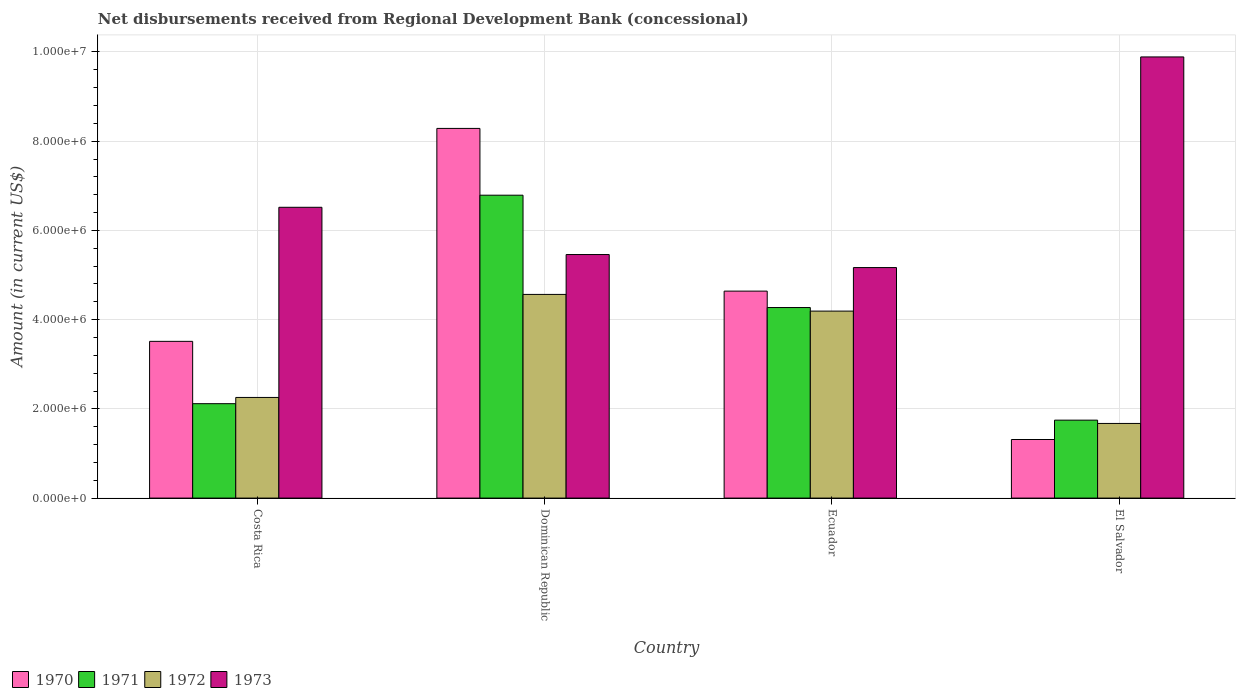How many different coloured bars are there?
Give a very brief answer. 4. How many bars are there on the 1st tick from the left?
Your answer should be compact. 4. How many bars are there on the 3rd tick from the right?
Your answer should be compact. 4. What is the label of the 4th group of bars from the left?
Give a very brief answer. El Salvador. In how many cases, is the number of bars for a given country not equal to the number of legend labels?
Give a very brief answer. 0. What is the amount of disbursements received from Regional Development Bank in 1972 in Costa Rica?
Your response must be concise. 2.26e+06. Across all countries, what is the maximum amount of disbursements received from Regional Development Bank in 1971?
Your response must be concise. 6.79e+06. Across all countries, what is the minimum amount of disbursements received from Regional Development Bank in 1971?
Your answer should be compact. 1.75e+06. In which country was the amount of disbursements received from Regional Development Bank in 1970 maximum?
Ensure brevity in your answer.  Dominican Republic. In which country was the amount of disbursements received from Regional Development Bank in 1972 minimum?
Offer a very short reply. El Salvador. What is the total amount of disbursements received from Regional Development Bank in 1971 in the graph?
Offer a terse response. 1.49e+07. What is the difference between the amount of disbursements received from Regional Development Bank in 1971 in Costa Rica and that in El Salvador?
Make the answer very short. 3.69e+05. What is the difference between the amount of disbursements received from Regional Development Bank in 1972 in Costa Rica and the amount of disbursements received from Regional Development Bank in 1973 in Dominican Republic?
Keep it short and to the point. -3.20e+06. What is the average amount of disbursements received from Regional Development Bank in 1971 per country?
Keep it short and to the point. 3.73e+06. What is the difference between the amount of disbursements received from Regional Development Bank of/in 1972 and amount of disbursements received from Regional Development Bank of/in 1973 in Costa Rica?
Give a very brief answer. -4.26e+06. In how many countries, is the amount of disbursements received from Regional Development Bank in 1972 greater than 2400000 US$?
Ensure brevity in your answer.  2. What is the ratio of the amount of disbursements received from Regional Development Bank in 1972 in Costa Rica to that in Ecuador?
Give a very brief answer. 0.54. Is the difference between the amount of disbursements received from Regional Development Bank in 1972 in Costa Rica and Ecuador greater than the difference between the amount of disbursements received from Regional Development Bank in 1973 in Costa Rica and Ecuador?
Provide a succinct answer. No. What is the difference between the highest and the second highest amount of disbursements received from Regional Development Bank in 1970?
Make the answer very short. 3.65e+06. What is the difference between the highest and the lowest amount of disbursements received from Regional Development Bank in 1973?
Your response must be concise. 4.72e+06. In how many countries, is the amount of disbursements received from Regional Development Bank in 1970 greater than the average amount of disbursements received from Regional Development Bank in 1970 taken over all countries?
Your answer should be very brief. 2. Is the sum of the amount of disbursements received from Regional Development Bank in 1971 in Costa Rica and Dominican Republic greater than the maximum amount of disbursements received from Regional Development Bank in 1970 across all countries?
Keep it short and to the point. Yes. Is it the case that in every country, the sum of the amount of disbursements received from Regional Development Bank in 1970 and amount of disbursements received from Regional Development Bank in 1971 is greater than the amount of disbursements received from Regional Development Bank in 1972?
Offer a very short reply. Yes. How many countries are there in the graph?
Make the answer very short. 4. Are the values on the major ticks of Y-axis written in scientific E-notation?
Give a very brief answer. Yes. Does the graph contain any zero values?
Offer a terse response. No. Does the graph contain grids?
Keep it short and to the point. Yes. Where does the legend appear in the graph?
Ensure brevity in your answer.  Bottom left. How many legend labels are there?
Your answer should be very brief. 4. How are the legend labels stacked?
Provide a short and direct response. Horizontal. What is the title of the graph?
Give a very brief answer. Net disbursements received from Regional Development Bank (concessional). Does "2014" appear as one of the legend labels in the graph?
Ensure brevity in your answer.  No. What is the Amount (in current US$) of 1970 in Costa Rica?
Offer a very short reply. 3.51e+06. What is the Amount (in current US$) in 1971 in Costa Rica?
Ensure brevity in your answer.  2.12e+06. What is the Amount (in current US$) of 1972 in Costa Rica?
Provide a succinct answer. 2.26e+06. What is the Amount (in current US$) in 1973 in Costa Rica?
Offer a very short reply. 6.52e+06. What is the Amount (in current US$) in 1970 in Dominican Republic?
Offer a very short reply. 8.29e+06. What is the Amount (in current US$) of 1971 in Dominican Republic?
Ensure brevity in your answer.  6.79e+06. What is the Amount (in current US$) in 1972 in Dominican Republic?
Make the answer very short. 4.56e+06. What is the Amount (in current US$) of 1973 in Dominican Republic?
Make the answer very short. 5.46e+06. What is the Amount (in current US$) in 1970 in Ecuador?
Ensure brevity in your answer.  4.64e+06. What is the Amount (in current US$) of 1971 in Ecuador?
Make the answer very short. 4.27e+06. What is the Amount (in current US$) in 1972 in Ecuador?
Give a very brief answer. 4.19e+06. What is the Amount (in current US$) in 1973 in Ecuador?
Give a very brief answer. 5.17e+06. What is the Amount (in current US$) of 1970 in El Salvador?
Your answer should be compact. 1.31e+06. What is the Amount (in current US$) of 1971 in El Salvador?
Your answer should be compact. 1.75e+06. What is the Amount (in current US$) of 1972 in El Salvador?
Your response must be concise. 1.67e+06. What is the Amount (in current US$) in 1973 in El Salvador?
Offer a terse response. 9.89e+06. Across all countries, what is the maximum Amount (in current US$) of 1970?
Ensure brevity in your answer.  8.29e+06. Across all countries, what is the maximum Amount (in current US$) of 1971?
Make the answer very short. 6.79e+06. Across all countries, what is the maximum Amount (in current US$) in 1972?
Keep it short and to the point. 4.56e+06. Across all countries, what is the maximum Amount (in current US$) in 1973?
Your answer should be very brief. 9.89e+06. Across all countries, what is the minimum Amount (in current US$) in 1970?
Make the answer very short. 1.31e+06. Across all countries, what is the minimum Amount (in current US$) of 1971?
Offer a very short reply. 1.75e+06. Across all countries, what is the minimum Amount (in current US$) of 1972?
Provide a short and direct response. 1.67e+06. Across all countries, what is the minimum Amount (in current US$) of 1973?
Offer a very short reply. 5.17e+06. What is the total Amount (in current US$) of 1970 in the graph?
Provide a short and direct response. 1.78e+07. What is the total Amount (in current US$) in 1971 in the graph?
Make the answer very short. 1.49e+07. What is the total Amount (in current US$) of 1972 in the graph?
Provide a succinct answer. 1.27e+07. What is the total Amount (in current US$) of 1973 in the graph?
Make the answer very short. 2.70e+07. What is the difference between the Amount (in current US$) in 1970 in Costa Rica and that in Dominican Republic?
Offer a terse response. -4.77e+06. What is the difference between the Amount (in current US$) in 1971 in Costa Rica and that in Dominican Republic?
Make the answer very short. -4.67e+06. What is the difference between the Amount (in current US$) of 1972 in Costa Rica and that in Dominican Republic?
Your answer should be compact. -2.31e+06. What is the difference between the Amount (in current US$) of 1973 in Costa Rica and that in Dominican Republic?
Your answer should be very brief. 1.06e+06. What is the difference between the Amount (in current US$) in 1970 in Costa Rica and that in Ecuador?
Ensure brevity in your answer.  -1.13e+06. What is the difference between the Amount (in current US$) in 1971 in Costa Rica and that in Ecuador?
Your response must be concise. -2.16e+06. What is the difference between the Amount (in current US$) of 1972 in Costa Rica and that in Ecuador?
Your response must be concise. -1.94e+06. What is the difference between the Amount (in current US$) in 1973 in Costa Rica and that in Ecuador?
Provide a short and direct response. 1.35e+06. What is the difference between the Amount (in current US$) of 1970 in Costa Rica and that in El Salvador?
Offer a very short reply. 2.20e+06. What is the difference between the Amount (in current US$) in 1971 in Costa Rica and that in El Salvador?
Offer a terse response. 3.69e+05. What is the difference between the Amount (in current US$) of 1972 in Costa Rica and that in El Salvador?
Offer a terse response. 5.83e+05. What is the difference between the Amount (in current US$) in 1973 in Costa Rica and that in El Salvador?
Ensure brevity in your answer.  -3.37e+06. What is the difference between the Amount (in current US$) of 1970 in Dominican Republic and that in Ecuador?
Ensure brevity in your answer.  3.65e+06. What is the difference between the Amount (in current US$) of 1971 in Dominican Republic and that in Ecuador?
Offer a very short reply. 2.52e+06. What is the difference between the Amount (in current US$) of 1972 in Dominican Republic and that in Ecuador?
Your response must be concise. 3.74e+05. What is the difference between the Amount (in current US$) in 1973 in Dominican Republic and that in Ecuador?
Your answer should be very brief. 2.92e+05. What is the difference between the Amount (in current US$) of 1970 in Dominican Republic and that in El Salvador?
Keep it short and to the point. 6.97e+06. What is the difference between the Amount (in current US$) in 1971 in Dominican Republic and that in El Salvador?
Provide a succinct answer. 5.04e+06. What is the difference between the Amount (in current US$) in 1972 in Dominican Republic and that in El Salvador?
Provide a short and direct response. 2.89e+06. What is the difference between the Amount (in current US$) of 1973 in Dominican Republic and that in El Salvador?
Your response must be concise. -4.43e+06. What is the difference between the Amount (in current US$) of 1970 in Ecuador and that in El Salvador?
Your answer should be very brief. 3.33e+06. What is the difference between the Amount (in current US$) of 1971 in Ecuador and that in El Salvador?
Make the answer very short. 2.52e+06. What is the difference between the Amount (in current US$) in 1972 in Ecuador and that in El Salvador?
Offer a very short reply. 2.52e+06. What is the difference between the Amount (in current US$) of 1973 in Ecuador and that in El Salvador?
Your answer should be very brief. -4.72e+06. What is the difference between the Amount (in current US$) in 1970 in Costa Rica and the Amount (in current US$) in 1971 in Dominican Republic?
Your answer should be compact. -3.28e+06. What is the difference between the Amount (in current US$) of 1970 in Costa Rica and the Amount (in current US$) of 1972 in Dominican Republic?
Provide a succinct answer. -1.05e+06. What is the difference between the Amount (in current US$) of 1970 in Costa Rica and the Amount (in current US$) of 1973 in Dominican Republic?
Provide a succinct answer. -1.95e+06. What is the difference between the Amount (in current US$) in 1971 in Costa Rica and the Amount (in current US$) in 1972 in Dominican Republic?
Ensure brevity in your answer.  -2.45e+06. What is the difference between the Amount (in current US$) of 1971 in Costa Rica and the Amount (in current US$) of 1973 in Dominican Republic?
Your answer should be very brief. -3.34e+06. What is the difference between the Amount (in current US$) in 1972 in Costa Rica and the Amount (in current US$) in 1973 in Dominican Republic?
Ensure brevity in your answer.  -3.20e+06. What is the difference between the Amount (in current US$) of 1970 in Costa Rica and the Amount (in current US$) of 1971 in Ecuador?
Your response must be concise. -7.58e+05. What is the difference between the Amount (in current US$) of 1970 in Costa Rica and the Amount (in current US$) of 1972 in Ecuador?
Your answer should be very brief. -6.78e+05. What is the difference between the Amount (in current US$) of 1970 in Costa Rica and the Amount (in current US$) of 1973 in Ecuador?
Offer a terse response. -1.65e+06. What is the difference between the Amount (in current US$) in 1971 in Costa Rica and the Amount (in current US$) in 1972 in Ecuador?
Provide a short and direct response. -2.08e+06. What is the difference between the Amount (in current US$) of 1971 in Costa Rica and the Amount (in current US$) of 1973 in Ecuador?
Ensure brevity in your answer.  -3.05e+06. What is the difference between the Amount (in current US$) in 1972 in Costa Rica and the Amount (in current US$) in 1973 in Ecuador?
Your response must be concise. -2.91e+06. What is the difference between the Amount (in current US$) in 1970 in Costa Rica and the Amount (in current US$) in 1971 in El Salvador?
Your answer should be compact. 1.77e+06. What is the difference between the Amount (in current US$) of 1970 in Costa Rica and the Amount (in current US$) of 1972 in El Salvador?
Give a very brief answer. 1.84e+06. What is the difference between the Amount (in current US$) in 1970 in Costa Rica and the Amount (in current US$) in 1973 in El Salvador?
Your answer should be very brief. -6.38e+06. What is the difference between the Amount (in current US$) in 1971 in Costa Rica and the Amount (in current US$) in 1972 in El Salvador?
Your answer should be very brief. 4.43e+05. What is the difference between the Amount (in current US$) in 1971 in Costa Rica and the Amount (in current US$) in 1973 in El Salvador?
Your response must be concise. -7.77e+06. What is the difference between the Amount (in current US$) of 1972 in Costa Rica and the Amount (in current US$) of 1973 in El Salvador?
Make the answer very short. -7.63e+06. What is the difference between the Amount (in current US$) of 1970 in Dominican Republic and the Amount (in current US$) of 1971 in Ecuador?
Make the answer very short. 4.02e+06. What is the difference between the Amount (in current US$) of 1970 in Dominican Republic and the Amount (in current US$) of 1972 in Ecuador?
Ensure brevity in your answer.  4.10e+06. What is the difference between the Amount (in current US$) of 1970 in Dominican Republic and the Amount (in current US$) of 1973 in Ecuador?
Make the answer very short. 3.12e+06. What is the difference between the Amount (in current US$) of 1971 in Dominican Republic and the Amount (in current US$) of 1972 in Ecuador?
Offer a very short reply. 2.60e+06. What is the difference between the Amount (in current US$) in 1971 in Dominican Republic and the Amount (in current US$) in 1973 in Ecuador?
Your response must be concise. 1.62e+06. What is the difference between the Amount (in current US$) in 1972 in Dominican Republic and the Amount (in current US$) in 1973 in Ecuador?
Offer a terse response. -6.02e+05. What is the difference between the Amount (in current US$) of 1970 in Dominican Republic and the Amount (in current US$) of 1971 in El Salvador?
Make the answer very short. 6.54e+06. What is the difference between the Amount (in current US$) of 1970 in Dominican Republic and the Amount (in current US$) of 1972 in El Salvador?
Provide a short and direct response. 6.61e+06. What is the difference between the Amount (in current US$) of 1970 in Dominican Republic and the Amount (in current US$) of 1973 in El Salvador?
Ensure brevity in your answer.  -1.60e+06. What is the difference between the Amount (in current US$) of 1971 in Dominican Republic and the Amount (in current US$) of 1972 in El Salvador?
Provide a succinct answer. 5.12e+06. What is the difference between the Amount (in current US$) of 1971 in Dominican Republic and the Amount (in current US$) of 1973 in El Salvador?
Your response must be concise. -3.10e+06. What is the difference between the Amount (in current US$) in 1972 in Dominican Republic and the Amount (in current US$) in 1973 in El Salvador?
Give a very brief answer. -5.32e+06. What is the difference between the Amount (in current US$) of 1970 in Ecuador and the Amount (in current US$) of 1971 in El Salvador?
Give a very brief answer. 2.89e+06. What is the difference between the Amount (in current US$) of 1970 in Ecuador and the Amount (in current US$) of 1972 in El Salvador?
Give a very brief answer. 2.97e+06. What is the difference between the Amount (in current US$) in 1970 in Ecuador and the Amount (in current US$) in 1973 in El Salvador?
Provide a succinct answer. -5.25e+06. What is the difference between the Amount (in current US$) of 1971 in Ecuador and the Amount (in current US$) of 1972 in El Salvador?
Give a very brief answer. 2.60e+06. What is the difference between the Amount (in current US$) in 1971 in Ecuador and the Amount (in current US$) in 1973 in El Salvador?
Give a very brief answer. -5.62e+06. What is the difference between the Amount (in current US$) in 1972 in Ecuador and the Amount (in current US$) in 1973 in El Salvador?
Offer a terse response. -5.70e+06. What is the average Amount (in current US$) of 1970 per country?
Your answer should be compact. 4.44e+06. What is the average Amount (in current US$) in 1971 per country?
Ensure brevity in your answer.  3.73e+06. What is the average Amount (in current US$) in 1972 per country?
Provide a short and direct response. 3.17e+06. What is the average Amount (in current US$) in 1973 per country?
Keep it short and to the point. 6.76e+06. What is the difference between the Amount (in current US$) of 1970 and Amount (in current US$) of 1971 in Costa Rica?
Your answer should be compact. 1.40e+06. What is the difference between the Amount (in current US$) in 1970 and Amount (in current US$) in 1972 in Costa Rica?
Provide a succinct answer. 1.26e+06. What is the difference between the Amount (in current US$) in 1970 and Amount (in current US$) in 1973 in Costa Rica?
Keep it short and to the point. -3.00e+06. What is the difference between the Amount (in current US$) of 1971 and Amount (in current US$) of 1973 in Costa Rica?
Make the answer very short. -4.40e+06. What is the difference between the Amount (in current US$) of 1972 and Amount (in current US$) of 1973 in Costa Rica?
Give a very brief answer. -4.26e+06. What is the difference between the Amount (in current US$) in 1970 and Amount (in current US$) in 1971 in Dominican Republic?
Ensure brevity in your answer.  1.50e+06. What is the difference between the Amount (in current US$) of 1970 and Amount (in current US$) of 1972 in Dominican Republic?
Make the answer very short. 3.72e+06. What is the difference between the Amount (in current US$) in 1970 and Amount (in current US$) in 1973 in Dominican Republic?
Your answer should be compact. 2.83e+06. What is the difference between the Amount (in current US$) of 1971 and Amount (in current US$) of 1972 in Dominican Republic?
Your answer should be compact. 2.22e+06. What is the difference between the Amount (in current US$) of 1971 and Amount (in current US$) of 1973 in Dominican Republic?
Make the answer very short. 1.33e+06. What is the difference between the Amount (in current US$) of 1972 and Amount (in current US$) of 1973 in Dominican Republic?
Your response must be concise. -8.94e+05. What is the difference between the Amount (in current US$) of 1970 and Amount (in current US$) of 1971 in Ecuador?
Offer a terse response. 3.68e+05. What is the difference between the Amount (in current US$) in 1970 and Amount (in current US$) in 1972 in Ecuador?
Give a very brief answer. 4.48e+05. What is the difference between the Amount (in current US$) of 1970 and Amount (in current US$) of 1973 in Ecuador?
Provide a succinct answer. -5.28e+05. What is the difference between the Amount (in current US$) in 1971 and Amount (in current US$) in 1973 in Ecuador?
Your answer should be compact. -8.96e+05. What is the difference between the Amount (in current US$) in 1972 and Amount (in current US$) in 1973 in Ecuador?
Provide a succinct answer. -9.76e+05. What is the difference between the Amount (in current US$) in 1970 and Amount (in current US$) in 1971 in El Salvador?
Your answer should be very brief. -4.34e+05. What is the difference between the Amount (in current US$) of 1970 and Amount (in current US$) of 1972 in El Salvador?
Ensure brevity in your answer.  -3.60e+05. What is the difference between the Amount (in current US$) of 1970 and Amount (in current US$) of 1973 in El Salvador?
Ensure brevity in your answer.  -8.58e+06. What is the difference between the Amount (in current US$) of 1971 and Amount (in current US$) of 1972 in El Salvador?
Provide a succinct answer. 7.40e+04. What is the difference between the Amount (in current US$) of 1971 and Amount (in current US$) of 1973 in El Salvador?
Offer a very short reply. -8.14e+06. What is the difference between the Amount (in current US$) of 1972 and Amount (in current US$) of 1973 in El Salvador?
Provide a succinct answer. -8.22e+06. What is the ratio of the Amount (in current US$) in 1970 in Costa Rica to that in Dominican Republic?
Keep it short and to the point. 0.42. What is the ratio of the Amount (in current US$) in 1971 in Costa Rica to that in Dominican Republic?
Your answer should be compact. 0.31. What is the ratio of the Amount (in current US$) in 1972 in Costa Rica to that in Dominican Republic?
Keep it short and to the point. 0.49. What is the ratio of the Amount (in current US$) in 1973 in Costa Rica to that in Dominican Republic?
Give a very brief answer. 1.19. What is the ratio of the Amount (in current US$) in 1970 in Costa Rica to that in Ecuador?
Your answer should be very brief. 0.76. What is the ratio of the Amount (in current US$) of 1971 in Costa Rica to that in Ecuador?
Provide a succinct answer. 0.5. What is the ratio of the Amount (in current US$) in 1972 in Costa Rica to that in Ecuador?
Provide a short and direct response. 0.54. What is the ratio of the Amount (in current US$) in 1973 in Costa Rica to that in Ecuador?
Your answer should be very brief. 1.26. What is the ratio of the Amount (in current US$) of 1970 in Costa Rica to that in El Salvador?
Make the answer very short. 2.68. What is the ratio of the Amount (in current US$) in 1971 in Costa Rica to that in El Salvador?
Offer a very short reply. 1.21. What is the ratio of the Amount (in current US$) of 1972 in Costa Rica to that in El Salvador?
Offer a terse response. 1.35. What is the ratio of the Amount (in current US$) of 1973 in Costa Rica to that in El Salvador?
Provide a short and direct response. 0.66. What is the ratio of the Amount (in current US$) of 1970 in Dominican Republic to that in Ecuador?
Provide a succinct answer. 1.79. What is the ratio of the Amount (in current US$) in 1971 in Dominican Republic to that in Ecuador?
Offer a very short reply. 1.59. What is the ratio of the Amount (in current US$) of 1972 in Dominican Republic to that in Ecuador?
Your answer should be compact. 1.09. What is the ratio of the Amount (in current US$) of 1973 in Dominican Republic to that in Ecuador?
Ensure brevity in your answer.  1.06. What is the ratio of the Amount (in current US$) in 1970 in Dominican Republic to that in El Salvador?
Your answer should be compact. 6.31. What is the ratio of the Amount (in current US$) in 1971 in Dominican Republic to that in El Salvador?
Ensure brevity in your answer.  3.89. What is the ratio of the Amount (in current US$) of 1972 in Dominican Republic to that in El Salvador?
Provide a short and direct response. 2.73. What is the ratio of the Amount (in current US$) of 1973 in Dominican Republic to that in El Salvador?
Provide a succinct answer. 0.55. What is the ratio of the Amount (in current US$) in 1970 in Ecuador to that in El Salvador?
Make the answer very short. 3.53. What is the ratio of the Amount (in current US$) in 1971 in Ecuador to that in El Salvador?
Give a very brief answer. 2.44. What is the ratio of the Amount (in current US$) of 1972 in Ecuador to that in El Salvador?
Your answer should be compact. 2.51. What is the ratio of the Amount (in current US$) in 1973 in Ecuador to that in El Salvador?
Offer a very short reply. 0.52. What is the difference between the highest and the second highest Amount (in current US$) in 1970?
Keep it short and to the point. 3.65e+06. What is the difference between the highest and the second highest Amount (in current US$) of 1971?
Your answer should be compact. 2.52e+06. What is the difference between the highest and the second highest Amount (in current US$) in 1972?
Your answer should be compact. 3.74e+05. What is the difference between the highest and the second highest Amount (in current US$) of 1973?
Provide a succinct answer. 3.37e+06. What is the difference between the highest and the lowest Amount (in current US$) of 1970?
Offer a very short reply. 6.97e+06. What is the difference between the highest and the lowest Amount (in current US$) in 1971?
Keep it short and to the point. 5.04e+06. What is the difference between the highest and the lowest Amount (in current US$) of 1972?
Keep it short and to the point. 2.89e+06. What is the difference between the highest and the lowest Amount (in current US$) in 1973?
Make the answer very short. 4.72e+06. 